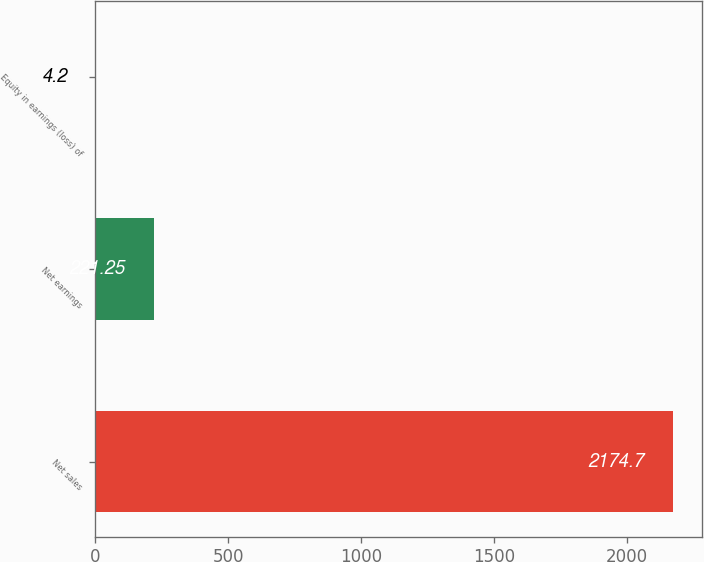Convert chart to OTSL. <chart><loc_0><loc_0><loc_500><loc_500><bar_chart><fcel>Net sales<fcel>Net earnings<fcel>Equity in earnings (loss) of<nl><fcel>2174.7<fcel>221.25<fcel>4.2<nl></chart> 